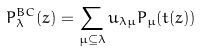<formula> <loc_0><loc_0><loc_500><loc_500>P ^ { B C } _ { \lambda } ( z ) = \sum _ { \mu \subseteq \lambda } u _ { \lambda \mu } P _ { \mu } ( t ( z ) )</formula> 